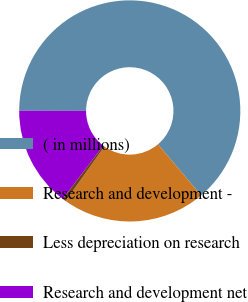<chart> <loc_0><loc_0><loc_500><loc_500><pie_chart><fcel>( in millions)<fcel>Research and development -<fcel>Less depreciation on research<fcel>Research and development net<nl><fcel>63.81%<fcel>21.01%<fcel>0.51%<fcel>14.68%<nl></chart> 